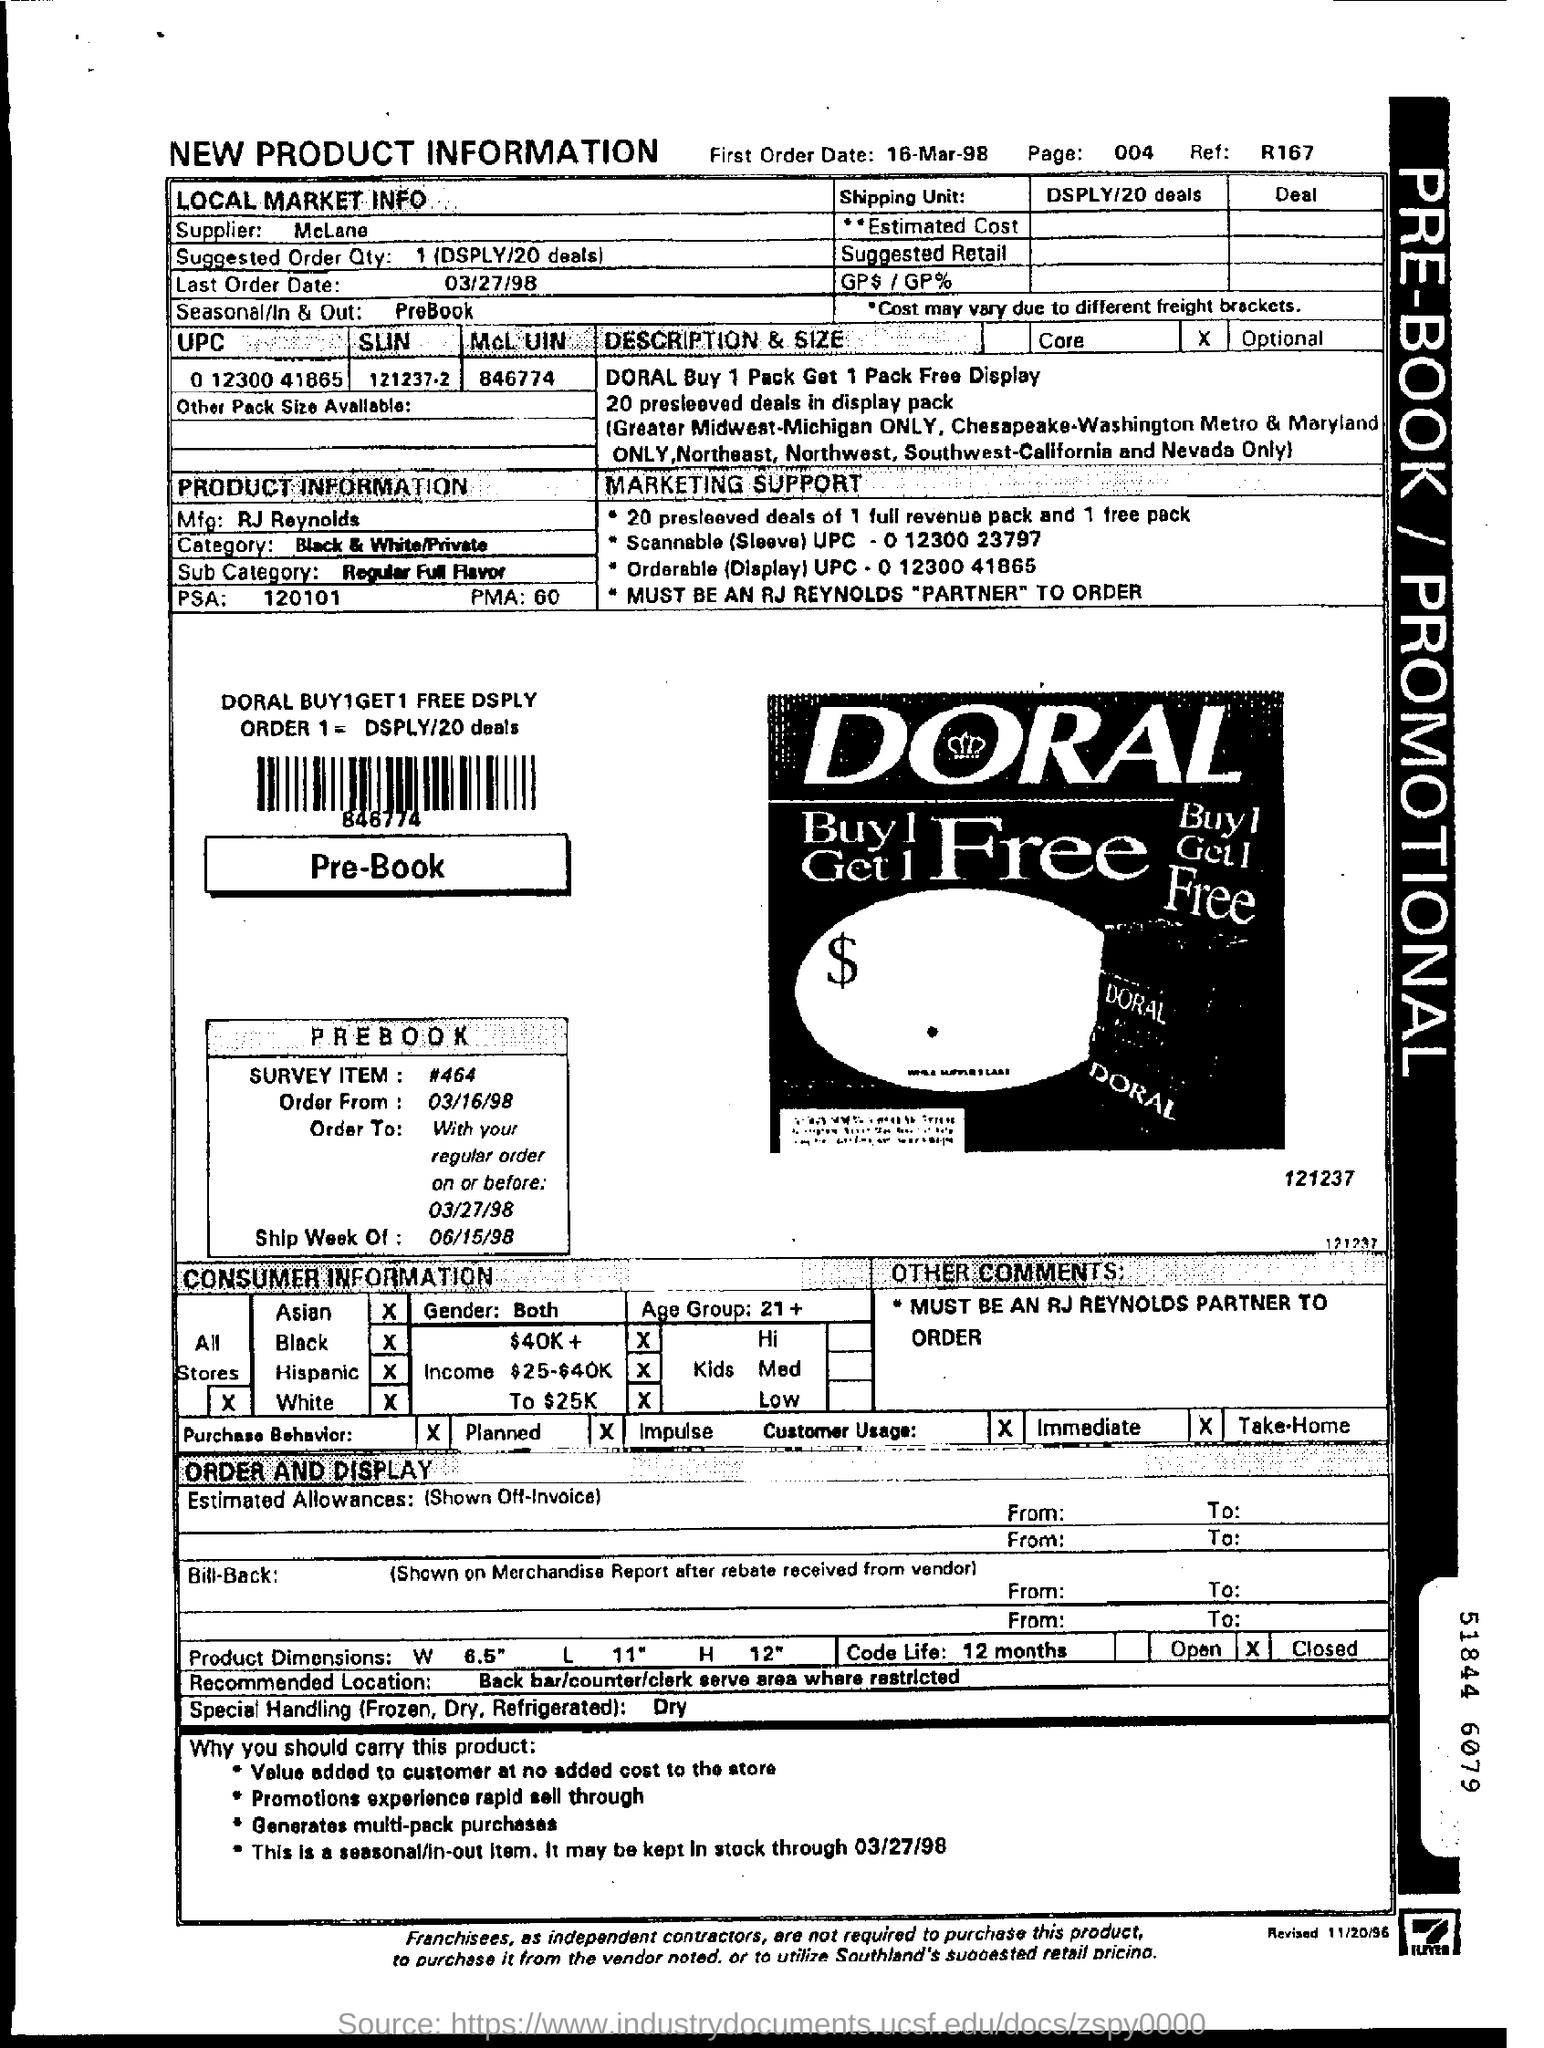What is the first order date?
Provide a succinct answer. 16-Mar-98. Who is the manufacturer?
Keep it short and to the point. RJ Reynolds. What is the suggested order quantity?
Keep it short and to the point. 1. What is the last order date?
Give a very brief answer. 03/27/98. 